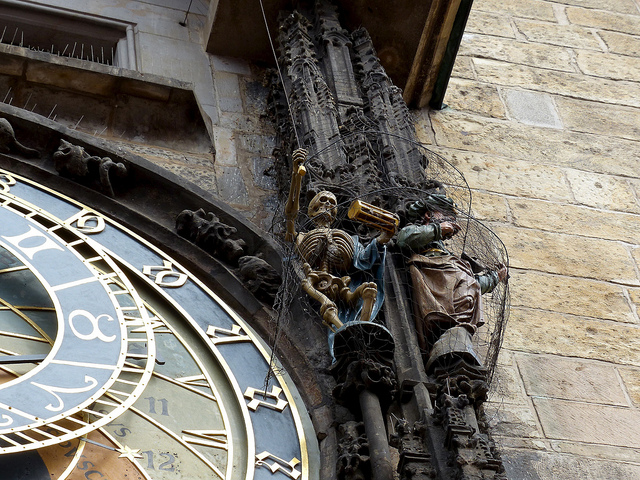<image>What is the Skeleton holding? It's ambiguous what the skeleton is holding. It could be a gold box, drum, chest, old lamp, wire, hourglass, cable, or cylinder. What is the Skeleton holding? It is not clear what the Skeleton is holding. It can be seen 'gold box', 'drum', 'chest', 'old lamp', 'wire', 'hourglass', 'cable', 'cylinder', or 'scroll'. 